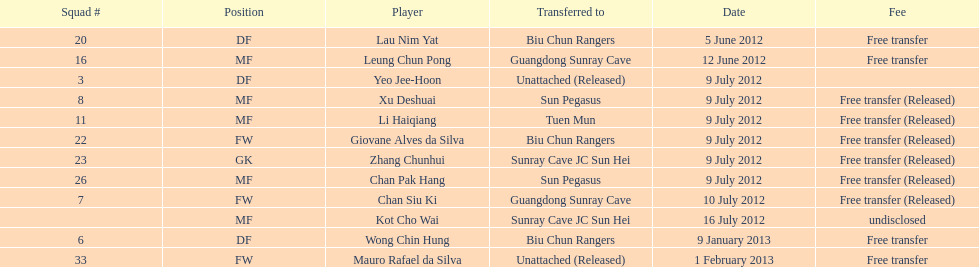Who is the first player listed? Lau Nim Yat. 